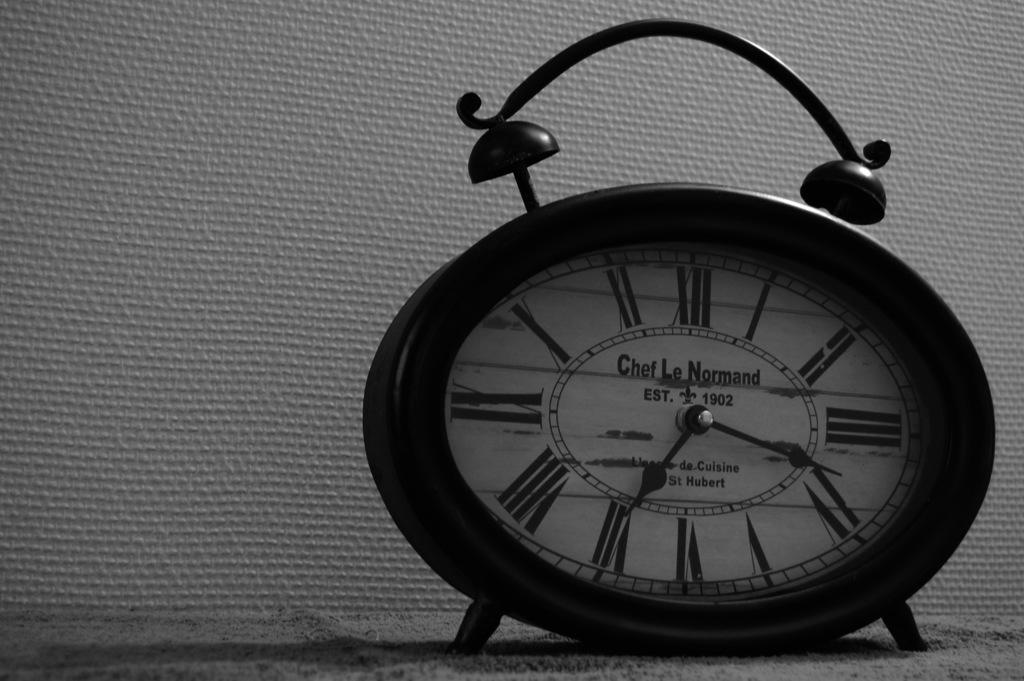What object in the image is used for measuring time? There is a clock in the image, which is used for measuring time. What surface is the clock placed on in the image? The clock is on the sand in the image. What type of structure is visible in the background of the image? There is a wall visible in the image. What type of pump can be seen in the image? There is no pump present in the image. What type of fruit is visible on the wall in the image? There is no fruit visible on the wall in the image. What type of drink is being served in the image? There is no drink present in the image. 